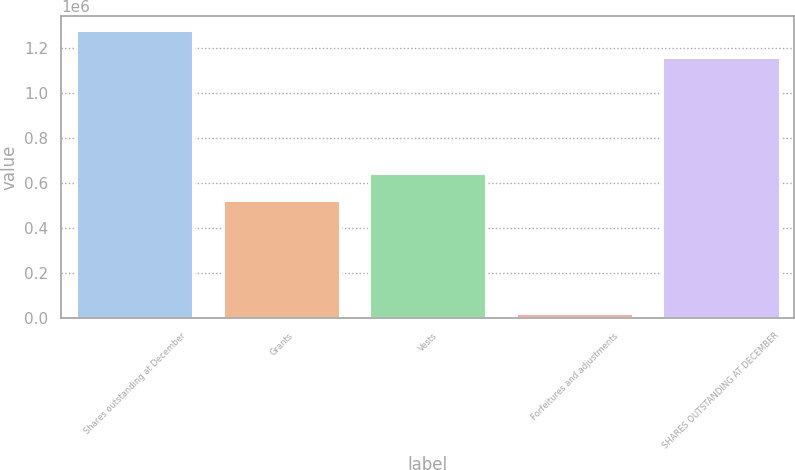Convert chart. <chart><loc_0><loc_0><loc_500><loc_500><bar_chart><fcel>Shares outstanding at December<fcel>Grants<fcel>Vests<fcel>Forfeitures and adjustments<fcel>SHARES OUTSTANDING AT DECEMBER<nl><fcel>1.27844e+06<fcel>525124<fcel>643470<fcel>22555<fcel>1.16009e+06<nl></chart> 